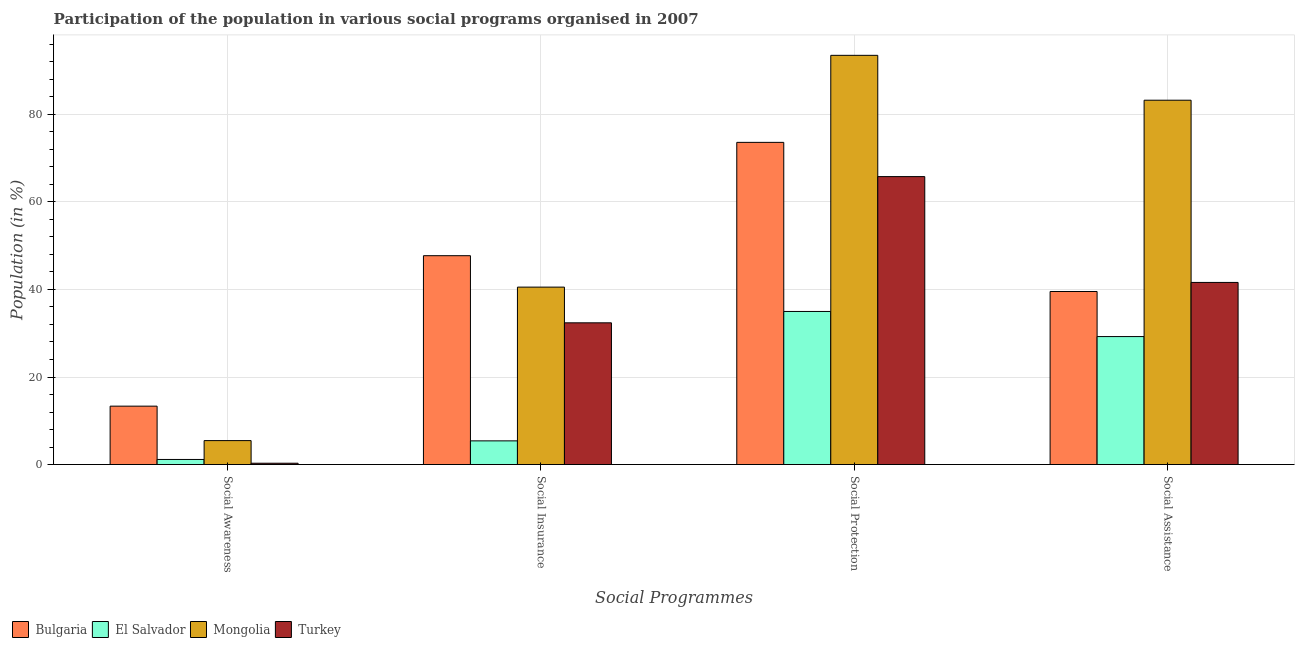How many groups of bars are there?
Your response must be concise. 4. Are the number of bars on each tick of the X-axis equal?
Ensure brevity in your answer.  Yes. What is the label of the 2nd group of bars from the left?
Provide a succinct answer. Social Insurance. What is the participation of population in social awareness programs in El Salvador?
Make the answer very short. 1.16. Across all countries, what is the maximum participation of population in social awareness programs?
Provide a succinct answer. 13.34. Across all countries, what is the minimum participation of population in social assistance programs?
Make the answer very short. 29.24. In which country was the participation of population in social assistance programs maximum?
Offer a very short reply. Mongolia. What is the total participation of population in social insurance programs in the graph?
Offer a very short reply. 126.04. What is the difference between the participation of population in social protection programs in Mongolia and that in El Salvador?
Offer a very short reply. 58.52. What is the difference between the participation of population in social insurance programs in Bulgaria and the participation of population in social assistance programs in Turkey?
Offer a terse response. 6.11. What is the average participation of population in social awareness programs per country?
Keep it short and to the point. 5.07. What is the difference between the participation of population in social awareness programs and participation of population in social assistance programs in Turkey?
Offer a terse response. -41.3. What is the ratio of the participation of population in social awareness programs in Bulgaria to that in El Salvador?
Your answer should be very brief. 11.51. Is the participation of population in social awareness programs in Mongolia less than that in Bulgaria?
Keep it short and to the point. Yes. What is the difference between the highest and the second highest participation of population in social assistance programs?
Your answer should be very brief. 41.63. What is the difference between the highest and the lowest participation of population in social insurance programs?
Ensure brevity in your answer.  42.31. What does the 2nd bar from the left in Social Assistance represents?
Offer a very short reply. El Salvador. What does the 2nd bar from the right in Social Awareness represents?
Your response must be concise. Mongolia. How many bars are there?
Ensure brevity in your answer.  16. How many countries are there in the graph?
Give a very brief answer. 4. Are the values on the major ticks of Y-axis written in scientific E-notation?
Provide a succinct answer. No. Does the graph contain any zero values?
Provide a short and direct response. No. Does the graph contain grids?
Provide a short and direct response. Yes. Where does the legend appear in the graph?
Provide a succinct answer. Bottom left. What is the title of the graph?
Make the answer very short. Participation of the population in various social programs organised in 2007. What is the label or title of the X-axis?
Your answer should be very brief. Social Programmes. What is the label or title of the Y-axis?
Offer a terse response. Population (in %). What is the Population (in %) in Bulgaria in Social Awareness?
Provide a succinct answer. 13.34. What is the Population (in %) of El Salvador in Social Awareness?
Keep it short and to the point. 1.16. What is the Population (in %) of Mongolia in Social Awareness?
Provide a succinct answer. 5.47. What is the Population (in %) of Turkey in Social Awareness?
Your answer should be compact. 0.3. What is the Population (in %) in Bulgaria in Social Insurance?
Provide a short and direct response. 47.72. What is the Population (in %) in El Salvador in Social Insurance?
Provide a succinct answer. 5.41. What is the Population (in %) in Mongolia in Social Insurance?
Ensure brevity in your answer.  40.54. What is the Population (in %) in Turkey in Social Insurance?
Offer a very short reply. 32.38. What is the Population (in %) of Bulgaria in Social Protection?
Your response must be concise. 73.61. What is the Population (in %) in El Salvador in Social Protection?
Make the answer very short. 34.97. What is the Population (in %) of Mongolia in Social Protection?
Give a very brief answer. 93.49. What is the Population (in %) in Turkey in Social Protection?
Offer a very short reply. 65.79. What is the Population (in %) in Bulgaria in Social Assistance?
Keep it short and to the point. 39.53. What is the Population (in %) in El Salvador in Social Assistance?
Provide a succinct answer. 29.24. What is the Population (in %) in Mongolia in Social Assistance?
Give a very brief answer. 83.24. What is the Population (in %) in Turkey in Social Assistance?
Provide a short and direct response. 41.61. Across all Social Programmes, what is the maximum Population (in %) in Bulgaria?
Ensure brevity in your answer.  73.61. Across all Social Programmes, what is the maximum Population (in %) of El Salvador?
Offer a very short reply. 34.97. Across all Social Programmes, what is the maximum Population (in %) of Mongolia?
Provide a short and direct response. 93.49. Across all Social Programmes, what is the maximum Population (in %) of Turkey?
Provide a short and direct response. 65.79. Across all Social Programmes, what is the minimum Population (in %) of Bulgaria?
Your answer should be very brief. 13.34. Across all Social Programmes, what is the minimum Population (in %) of El Salvador?
Offer a terse response. 1.16. Across all Social Programmes, what is the minimum Population (in %) of Mongolia?
Provide a short and direct response. 5.47. Across all Social Programmes, what is the minimum Population (in %) of Turkey?
Offer a terse response. 0.3. What is the total Population (in %) of Bulgaria in the graph?
Make the answer very short. 174.2. What is the total Population (in %) of El Salvador in the graph?
Give a very brief answer. 70.78. What is the total Population (in %) of Mongolia in the graph?
Keep it short and to the point. 222.73. What is the total Population (in %) in Turkey in the graph?
Give a very brief answer. 140.07. What is the difference between the Population (in %) in Bulgaria in Social Awareness and that in Social Insurance?
Keep it short and to the point. -34.38. What is the difference between the Population (in %) in El Salvador in Social Awareness and that in Social Insurance?
Your answer should be compact. -4.25. What is the difference between the Population (in %) in Mongolia in Social Awareness and that in Social Insurance?
Keep it short and to the point. -35.07. What is the difference between the Population (in %) in Turkey in Social Awareness and that in Social Insurance?
Ensure brevity in your answer.  -32.08. What is the difference between the Population (in %) of Bulgaria in Social Awareness and that in Social Protection?
Provide a short and direct response. -60.27. What is the difference between the Population (in %) of El Salvador in Social Awareness and that in Social Protection?
Offer a very short reply. -33.81. What is the difference between the Population (in %) in Mongolia in Social Awareness and that in Social Protection?
Your answer should be very brief. -88.02. What is the difference between the Population (in %) of Turkey in Social Awareness and that in Social Protection?
Provide a short and direct response. -65.49. What is the difference between the Population (in %) in Bulgaria in Social Awareness and that in Social Assistance?
Give a very brief answer. -26.2. What is the difference between the Population (in %) of El Salvador in Social Awareness and that in Social Assistance?
Your response must be concise. -28.08. What is the difference between the Population (in %) of Mongolia in Social Awareness and that in Social Assistance?
Your answer should be very brief. -77.77. What is the difference between the Population (in %) in Turkey in Social Awareness and that in Social Assistance?
Your response must be concise. -41.3. What is the difference between the Population (in %) of Bulgaria in Social Insurance and that in Social Protection?
Keep it short and to the point. -25.89. What is the difference between the Population (in %) in El Salvador in Social Insurance and that in Social Protection?
Offer a very short reply. -29.56. What is the difference between the Population (in %) in Mongolia in Social Insurance and that in Social Protection?
Provide a short and direct response. -52.96. What is the difference between the Population (in %) of Turkey in Social Insurance and that in Social Protection?
Your answer should be compact. -33.41. What is the difference between the Population (in %) of Bulgaria in Social Insurance and that in Social Assistance?
Make the answer very short. 8.18. What is the difference between the Population (in %) in El Salvador in Social Insurance and that in Social Assistance?
Offer a terse response. -23.83. What is the difference between the Population (in %) in Mongolia in Social Insurance and that in Social Assistance?
Your answer should be compact. -42.7. What is the difference between the Population (in %) of Turkey in Social Insurance and that in Social Assistance?
Provide a succinct answer. -9.23. What is the difference between the Population (in %) of Bulgaria in Social Protection and that in Social Assistance?
Your answer should be compact. 34.07. What is the difference between the Population (in %) in El Salvador in Social Protection and that in Social Assistance?
Give a very brief answer. 5.74. What is the difference between the Population (in %) in Mongolia in Social Protection and that in Social Assistance?
Offer a terse response. 10.25. What is the difference between the Population (in %) of Turkey in Social Protection and that in Social Assistance?
Make the answer very short. 24.18. What is the difference between the Population (in %) of Bulgaria in Social Awareness and the Population (in %) of El Salvador in Social Insurance?
Give a very brief answer. 7.93. What is the difference between the Population (in %) in Bulgaria in Social Awareness and the Population (in %) in Mongolia in Social Insurance?
Make the answer very short. -27.2. What is the difference between the Population (in %) in Bulgaria in Social Awareness and the Population (in %) in Turkey in Social Insurance?
Provide a short and direct response. -19.04. What is the difference between the Population (in %) of El Salvador in Social Awareness and the Population (in %) of Mongolia in Social Insurance?
Provide a succinct answer. -39.38. What is the difference between the Population (in %) of El Salvador in Social Awareness and the Population (in %) of Turkey in Social Insurance?
Your answer should be compact. -31.22. What is the difference between the Population (in %) in Mongolia in Social Awareness and the Population (in %) in Turkey in Social Insurance?
Ensure brevity in your answer.  -26.91. What is the difference between the Population (in %) in Bulgaria in Social Awareness and the Population (in %) in El Salvador in Social Protection?
Offer a very short reply. -21.63. What is the difference between the Population (in %) of Bulgaria in Social Awareness and the Population (in %) of Mongolia in Social Protection?
Offer a very short reply. -80.15. What is the difference between the Population (in %) in Bulgaria in Social Awareness and the Population (in %) in Turkey in Social Protection?
Give a very brief answer. -52.45. What is the difference between the Population (in %) in El Salvador in Social Awareness and the Population (in %) in Mongolia in Social Protection?
Offer a very short reply. -92.33. What is the difference between the Population (in %) in El Salvador in Social Awareness and the Population (in %) in Turkey in Social Protection?
Your response must be concise. -64.63. What is the difference between the Population (in %) of Mongolia in Social Awareness and the Population (in %) of Turkey in Social Protection?
Give a very brief answer. -60.32. What is the difference between the Population (in %) of Bulgaria in Social Awareness and the Population (in %) of El Salvador in Social Assistance?
Your response must be concise. -15.9. What is the difference between the Population (in %) in Bulgaria in Social Awareness and the Population (in %) in Mongolia in Social Assistance?
Provide a succinct answer. -69.9. What is the difference between the Population (in %) of Bulgaria in Social Awareness and the Population (in %) of Turkey in Social Assistance?
Give a very brief answer. -28.27. What is the difference between the Population (in %) of El Salvador in Social Awareness and the Population (in %) of Mongolia in Social Assistance?
Keep it short and to the point. -82.08. What is the difference between the Population (in %) of El Salvador in Social Awareness and the Population (in %) of Turkey in Social Assistance?
Your answer should be compact. -40.45. What is the difference between the Population (in %) in Mongolia in Social Awareness and the Population (in %) in Turkey in Social Assistance?
Give a very brief answer. -36.14. What is the difference between the Population (in %) of Bulgaria in Social Insurance and the Population (in %) of El Salvador in Social Protection?
Your answer should be compact. 12.74. What is the difference between the Population (in %) in Bulgaria in Social Insurance and the Population (in %) in Mongolia in Social Protection?
Your answer should be compact. -45.78. What is the difference between the Population (in %) of Bulgaria in Social Insurance and the Population (in %) of Turkey in Social Protection?
Offer a terse response. -18.07. What is the difference between the Population (in %) of El Salvador in Social Insurance and the Population (in %) of Mongolia in Social Protection?
Your answer should be compact. -88.08. What is the difference between the Population (in %) of El Salvador in Social Insurance and the Population (in %) of Turkey in Social Protection?
Keep it short and to the point. -60.38. What is the difference between the Population (in %) of Mongolia in Social Insurance and the Population (in %) of Turkey in Social Protection?
Provide a succinct answer. -25.25. What is the difference between the Population (in %) in Bulgaria in Social Insurance and the Population (in %) in El Salvador in Social Assistance?
Ensure brevity in your answer.  18.48. What is the difference between the Population (in %) of Bulgaria in Social Insurance and the Population (in %) of Mongolia in Social Assistance?
Keep it short and to the point. -35.52. What is the difference between the Population (in %) of Bulgaria in Social Insurance and the Population (in %) of Turkey in Social Assistance?
Make the answer very short. 6.11. What is the difference between the Population (in %) in El Salvador in Social Insurance and the Population (in %) in Mongolia in Social Assistance?
Your answer should be compact. -77.83. What is the difference between the Population (in %) in El Salvador in Social Insurance and the Population (in %) in Turkey in Social Assistance?
Give a very brief answer. -36.2. What is the difference between the Population (in %) in Mongolia in Social Insurance and the Population (in %) in Turkey in Social Assistance?
Your response must be concise. -1.07. What is the difference between the Population (in %) of Bulgaria in Social Protection and the Population (in %) of El Salvador in Social Assistance?
Make the answer very short. 44.37. What is the difference between the Population (in %) in Bulgaria in Social Protection and the Population (in %) in Mongolia in Social Assistance?
Ensure brevity in your answer.  -9.63. What is the difference between the Population (in %) of Bulgaria in Social Protection and the Population (in %) of Turkey in Social Assistance?
Offer a very short reply. 32. What is the difference between the Population (in %) of El Salvador in Social Protection and the Population (in %) of Mongolia in Social Assistance?
Your answer should be compact. -48.27. What is the difference between the Population (in %) in El Salvador in Social Protection and the Population (in %) in Turkey in Social Assistance?
Offer a terse response. -6.63. What is the difference between the Population (in %) of Mongolia in Social Protection and the Population (in %) of Turkey in Social Assistance?
Your answer should be very brief. 51.89. What is the average Population (in %) of Bulgaria per Social Programmes?
Provide a succinct answer. 43.55. What is the average Population (in %) in El Salvador per Social Programmes?
Ensure brevity in your answer.  17.69. What is the average Population (in %) in Mongolia per Social Programmes?
Offer a very short reply. 55.68. What is the average Population (in %) of Turkey per Social Programmes?
Keep it short and to the point. 35.02. What is the difference between the Population (in %) in Bulgaria and Population (in %) in El Salvador in Social Awareness?
Offer a terse response. 12.18. What is the difference between the Population (in %) of Bulgaria and Population (in %) of Mongolia in Social Awareness?
Offer a very short reply. 7.87. What is the difference between the Population (in %) in Bulgaria and Population (in %) in Turkey in Social Awareness?
Offer a very short reply. 13.04. What is the difference between the Population (in %) of El Salvador and Population (in %) of Mongolia in Social Awareness?
Give a very brief answer. -4.31. What is the difference between the Population (in %) in El Salvador and Population (in %) in Turkey in Social Awareness?
Your answer should be compact. 0.86. What is the difference between the Population (in %) of Mongolia and Population (in %) of Turkey in Social Awareness?
Your response must be concise. 5.17. What is the difference between the Population (in %) in Bulgaria and Population (in %) in El Salvador in Social Insurance?
Keep it short and to the point. 42.31. What is the difference between the Population (in %) in Bulgaria and Population (in %) in Mongolia in Social Insurance?
Provide a short and direct response. 7.18. What is the difference between the Population (in %) of Bulgaria and Population (in %) of Turkey in Social Insurance?
Your answer should be compact. 15.34. What is the difference between the Population (in %) in El Salvador and Population (in %) in Mongolia in Social Insurance?
Give a very brief answer. -35.13. What is the difference between the Population (in %) of El Salvador and Population (in %) of Turkey in Social Insurance?
Provide a short and direct response. -26.97. What is the difference between the Population (in %) in Mongolia and Population (in %) in Turkey in Social Insurance?
Ensure brevity in your answer.  8.16. What is the difference between the Population (in %) of Bulgaria and Population (in %) of El Salvador in Social Protection?
Your response must be concise. 38.64. What is the difference between the Population (in %) in Bulgaria and Population (in %) in Mongolia in Social Protection?
Provide a short and direct response. -19.88. What is the difference between the Population (in %) in Bulgaria and Population (in %) in Turkey in Social Protection?
Ensure brevity in your answer.  7.82. What is the difference between the Population (in %) in El Salvador and Population (in %) in Mongolia in Social Protection?
Give a very brief answer. -58.52. What is the difference between the Population (in %) in El Salvador and Population (in %) in Turkey in Social Protection?
Give a very brief answer. -30.81. What is the difference between the Population (in %) in Mongolia and Population (in %) in Turkey in Social Protection?
Offer a terse response. 27.7. What is the difference between the Population (in %) in Bulgaria and Population (in %) in El Salvador in Social Assistance?
Offer a very short reply. 10.3. What is the difference between the Population (in %) of Bulgaria and Population (in %) of Mongolia in Social Assistance?
Offer a very short reply. -43.7. What is the difference between the Population (in %) in Bulgaria and Population (in %) in Turkey in Social Assistance?
Offer a terse response. -2.07. What is the difference between the Population (in %) in El Salvador and Population (in %) in Mongolia in Social Assistance?
Keep it short and to the point. -54. What is the difference between the Population (in %) of El Salvador and Population (in %) of Turkey in Social Assistance?
Provide a succinct answer. -12.37. What is the difference between the Population (in %) of Mongolia and Population (in %) of Turkey in Social Assistance?
Give a very brief answer. 41.63. What is the ratio of the Population (in %) of Bulgaria in Social Awareness to that in Social Insurance?
Give a very brief answer. 0.28. What is the ratio of the Population (in %) of El Salvador in Social Awareness to that in Social Insurance?
Your answer should be compact. 0.21. What is the ratio of the Population (in %) in Mongolia in Social Awareness to that in Social Insurance?
Give a very brief answer. 0.13. What is the ratio of the Population (in %) in Turkey in Social Awareness to that in Social Insurance?
Your response must be concise. 0.01. What is the ratio of the Population (in %) of Bulgaria in Social Awareness to that in Social Protection?
Ensure brevity in your answer.  0.18. What is the ratio of the Population (in %) of El Salvador in Social Awareness to that in Social Protection?
Give a very brief answer. 0.03. What is the ratio of the Population (in %) in Mongolia in Social Awareness to that in Social Protection?
Ensure brevity in your answer.  0.06. What is the ratio of the Population (in %) of Turkey in Social Awareness to that in Social Protection?
Provide a succinct answer. 0. What is the ratio of the Population (in %) of Bulgaria in Social Awareness to that in Social Assistance?
Your answer should be compact. 0.34. What is the ratio of the Population (in %) in El Salvador in Social Awareness to that in Social Assistance?
Provide a succinct answer. 0.04. What is the ratio of the Population (in %) of Mongolia in Social Awareness to that in Social Assistance?
Your answer should be very brief. 0.07. What is the ratio of the Population (in %) of Turkey in Social Awareness to that in Social Assistance?
Provide a succinct answer. 0.01. What is the ratio of the Population (in %) in Bulgaria in Social Insurance to that in Social Protection?
Your response must be concise. 0.65. What is the ratio of the Population (in %) of El Salvador in Social Insurance to that in Social Protection?
Your answer should be very brief. 0.15. What is the ratio of the Population (in %) in Mongolia in Social Insurance to that in Social Protection?
Offer a terse response. 0.43. What is the ratio of the Population (in %) in Turkey in Social Insurance to that in Social Protection?
Your answer should be compact. 0.49. What is the ratio of the Population (in %) in Bulgaria in Social Insurance to that in Social Assistance?
Keep it short and to the point. 1.21. What is the ratio of the Population (in %) of El Salvador in Social Insurance to that in Social Assistance?
Your answer should be very brief. 0.18. What is the ratio of the Population (in %) in Mongolia in Social Insurance to that in Social Assistance?
Make the answer very short. 0.49. What is the ratio of the Population (in %) of Turkey in Social Insurance to that in Social Assistance?
Provide a short and direct response. 0.78. What is the ratio of the Population (in %) of Bulgaria in Social Protection to that in Social Assistance?
Provide a short and direct response. 1.86. What is the ratio of the Population (in %) of El Salvador in Social Protection to that in Social Assistance?
Keep it short and to the point. 1.2. What is the ratio of the Population (in %) in Mongolia in Social Protection to that in Social Assistance?
Offer a terse response. 1.12. What is the ratio of the Population (in %) of Turkey in Social Protection to that in Social Assistance?
Offer a terse response. 1.58. What is the difference between the highest and the second highest Population (in %) of Bulgaria?
Your answer should be very brief. 25.89. What is the difference between the highest and the second highest Population (in %) in El Salvador?
Your answer should be very brief. 5.74. What is the difference between the highest and the second highest Population (in %) in Mongolia?
Provide a succinct answer. 10.25. What is the difference between the highest and the second highest Population (in %) in Turkey?
Your answer should be compact. 24.18. What is the difference between the highest and the lowest Population (in %) in Bulgaria?
Keep it short and to the point. 60.27. What is the difference between the highest and the lowest Population (in %) in El Salvador?
Provide a succinct answer. 33.81. What is the difference between the highest and the lowest Population (in %) of Mongolia?
Your response must be concise. 88.02. What is the difference between the highest and the lowest Population (in %) of Turkey?
Your response must be concise. 65.49. 